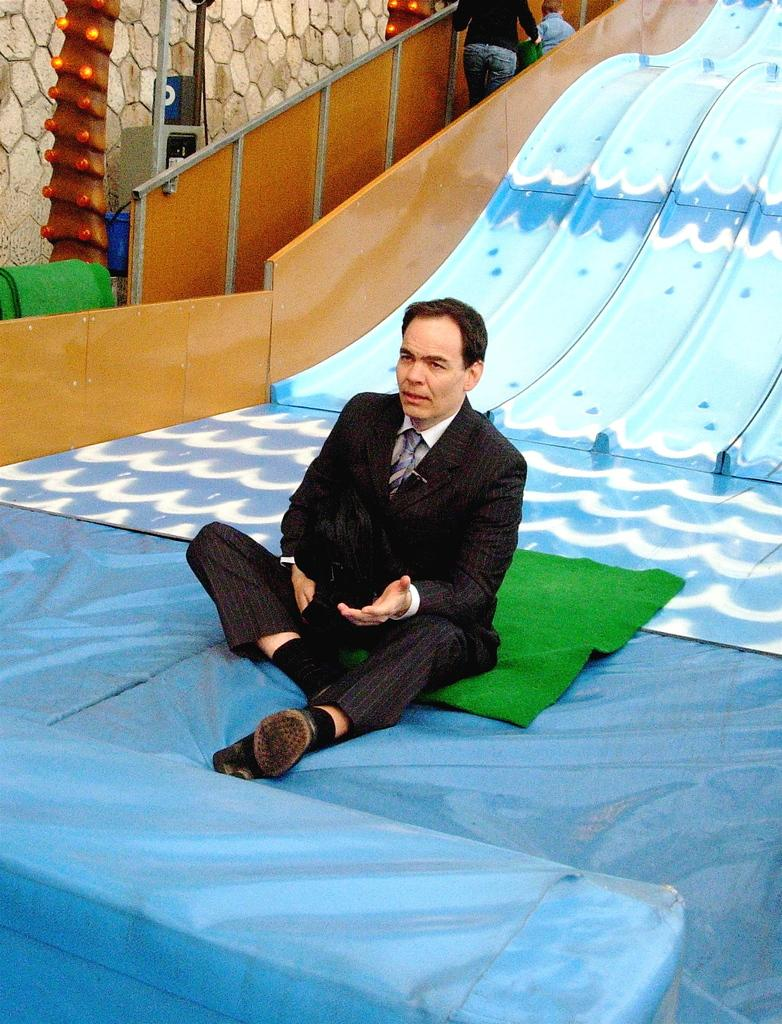What is present on the floor in the image? There is a sheet and green carpets in the image. What structures are visible in the image? Railings, slides, and a wall are visible in the image. What type of lighting is present in the image? Bulbs are in the image. Are there any poles in the image? Yes, poles are in the image. What is hanging on the wall in the image? A signboard is in the image. How many people are in the image? There are two people in the image. Can you describe the youngest person in the image? There is a kid in the image. What is one man doing in the image? One man is sitting on a green carpet. What type of punishment is being administered to the kid in the image? There is no punishment being administered to the kid in the image. What type of silver object can be seen in the image? There is no silver object present in the image. 